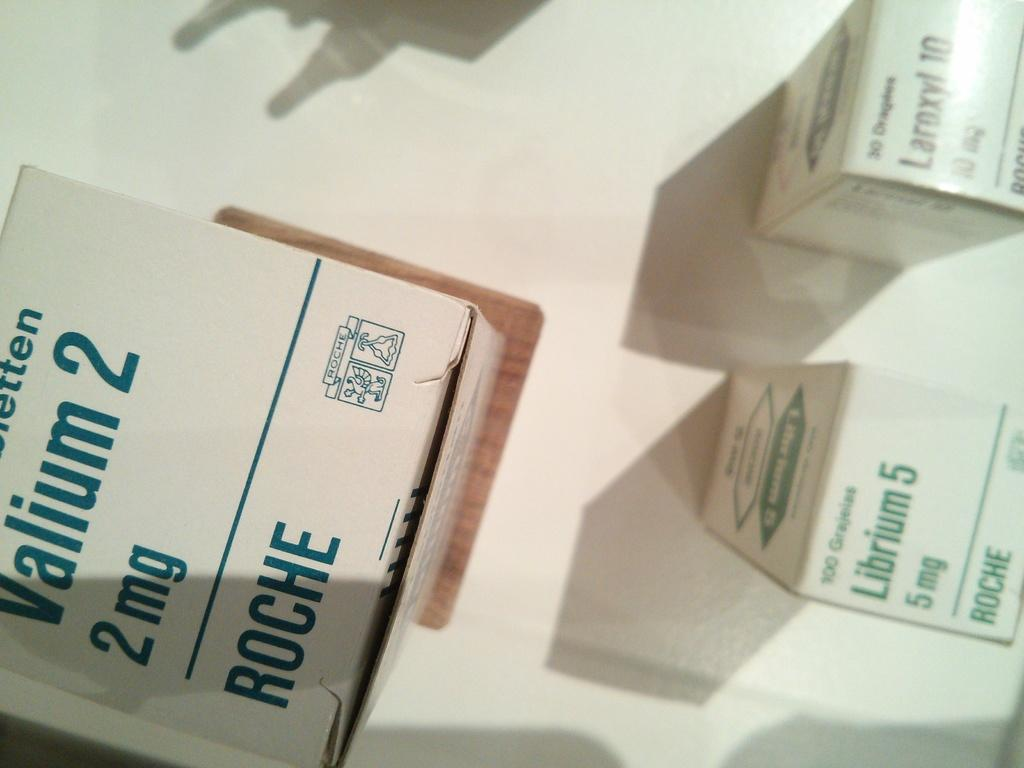<image>
Offer a succinct explanation of the picture presented. A box of Valium 2, 2mg from Roche 